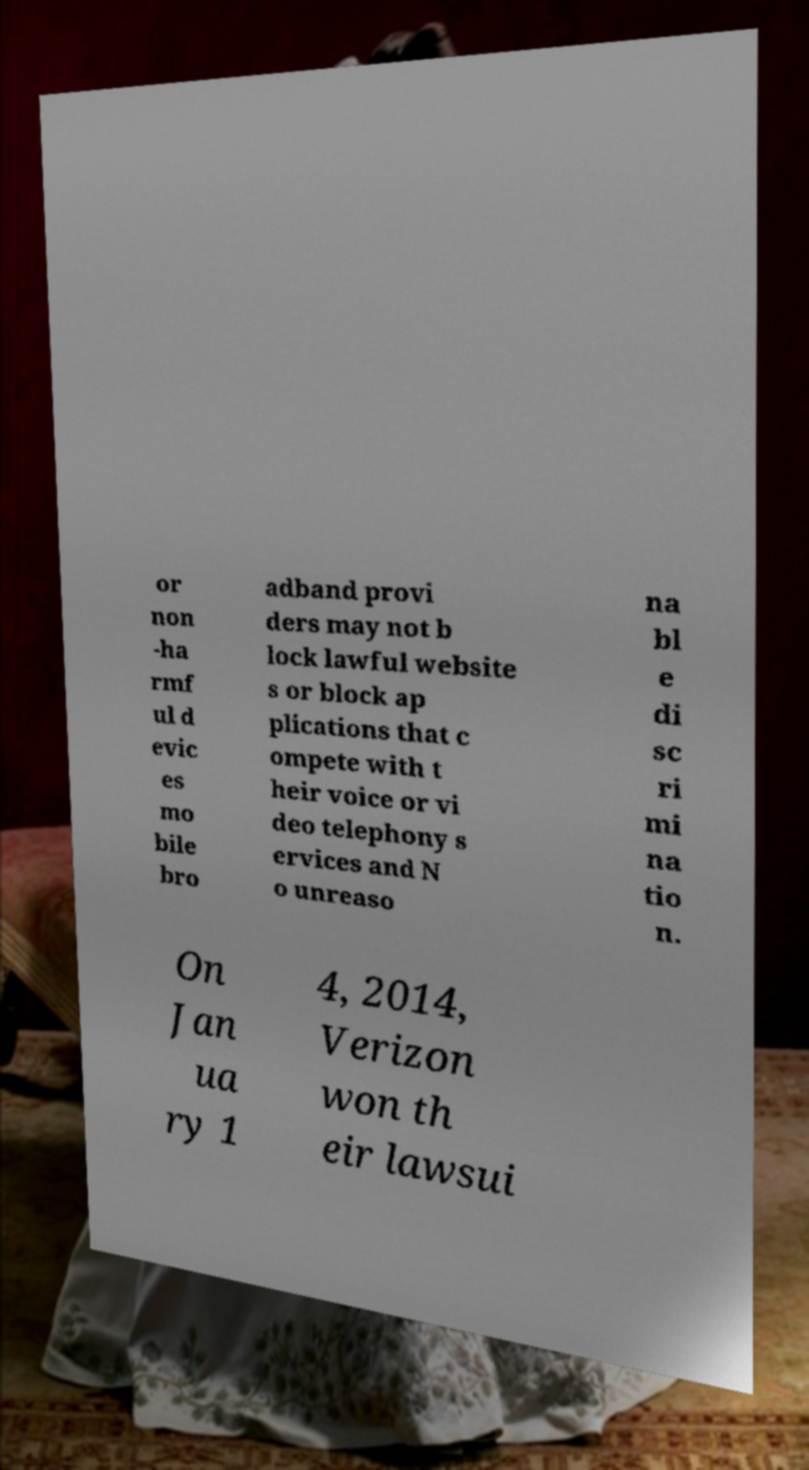Please identify and transcribe the text found in this image. or non -ha rmf ul d evic es mo bile bro adband provi ders may not b lock lawful website s or block ap plications that c ompete with t heir voice or vi deo telephony s ervices and N o unreaso na bl e di sc ri mi na tio n. On Jan ua ry 1 4, 2014, Verizon won th eir lawsui 